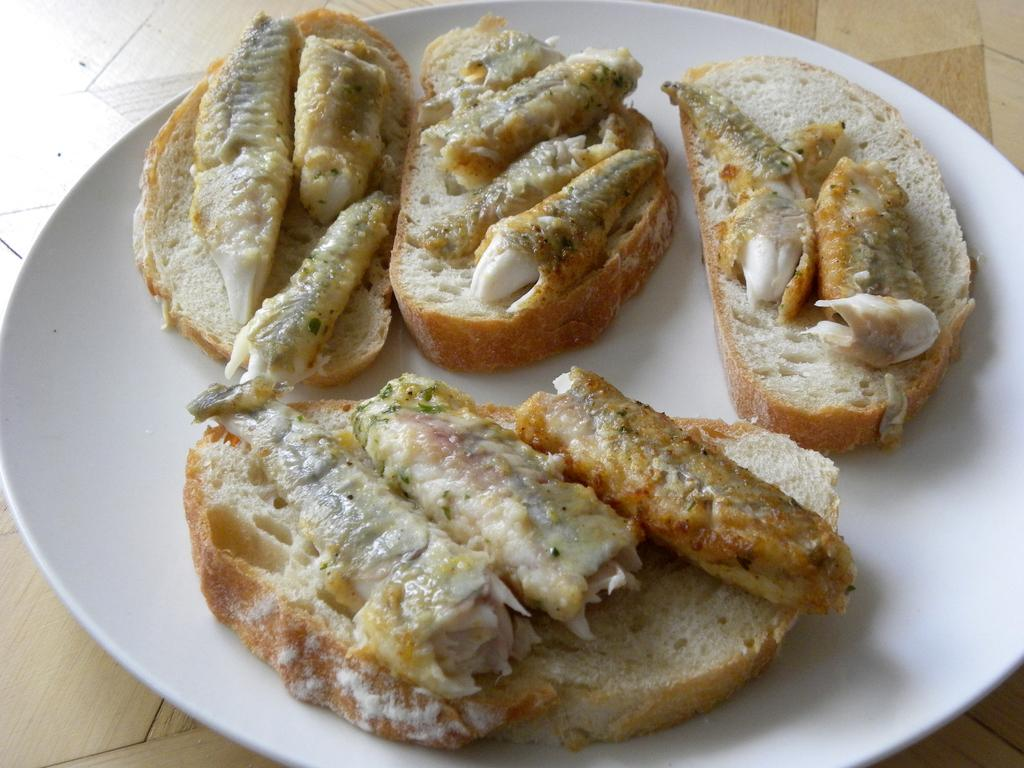What is present on the plate in the image? There are bread pieces on the plate in the image. Can you describe the plate in more detail? Unfortunately, the facts provided do not give any additional details about the plate. What color is the crayon used to draw on the wood in the image? There is no wood or crayon present in the image; it only features a plate with bread pieces. 